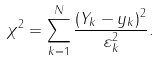Convert formula to latex. <formula><loc_0><loc_0><loc_500><loc_500>\chi ^ { 2 } = \sum _ { k = 1 } ^ { N } \frac { \left ( Y _ { k } - y _ { k } \right ) ^ { 2 } } { \varepsilon _ { k } ^ { 2 } } .</formula> 